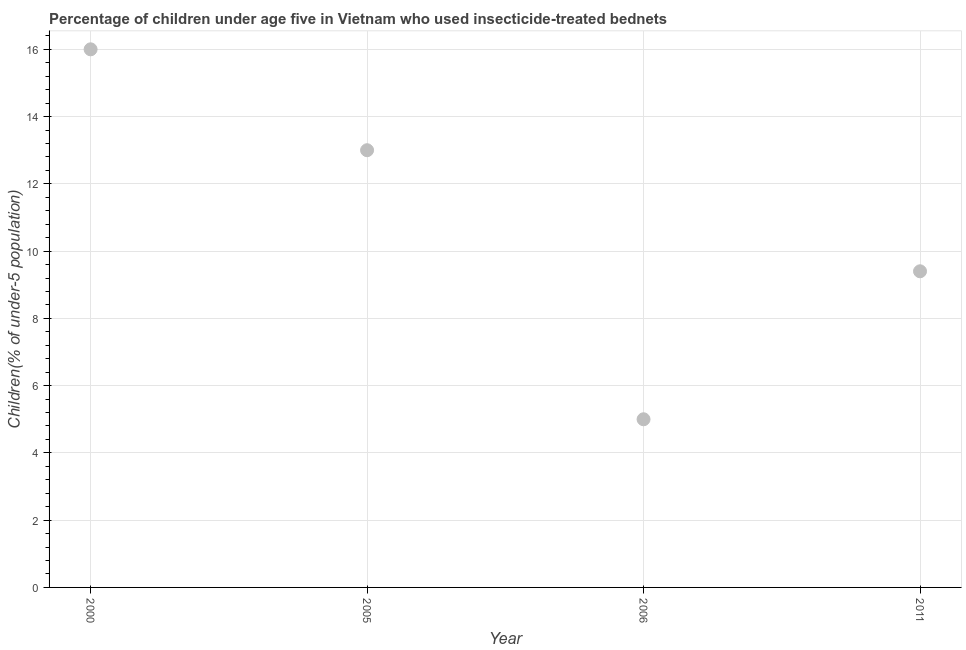What is the percentage of children who use of insecticide-treated bed nets in 2005?
Your answer should be compact. 13. Across all years, what is the maximum percentage of children who use of insecticide-treated bed nets?
Provide a short and direct response. 16. Across all years, what is the minimum percentage of children who use of insecticide-treated bed nets?
Offer a terse response. 5. In which year was the percentage of children who use of insecticide-treated bed nets maximum?
Offer a very short reply. 2000. In which year was the percentage of children who use of insecticide-treated bed nets minimum?
Provide a short and direct response. 2006. What is the sum of the percentage of children who use of insecticide-treated bed nets?
Offer a very short reply. 43.4. What is the average percentage of children who use of insecticide-treated bed nets per year?
Offer a terse response. 10.85. Do a majority of the years between 2005 and 2000 (inclusive) have percentage of children who use of insecticide-treated bed nets greater than 12.8 %?
Give a very brief answer. No. What is the ratio of the percentage of children who use of insecticide-treated bed nets in 2000 to that in 2011?
Offer a very short reply. 1.7. Is the difference between the percentage of children who use of insecticide-treated bed nets in 2005 and 2006 greater than the difference between any two years?
Give a very brief answer. No. What is the difference between the highest and the second highest percentage of children who use of insecticide-treated bed nets?
Give a very brief answer. 3. What is the difference between the highest and the lowest percentage of children who use of insecticide-treated bed nets?
Give a very brief answer. 11. Does the percentage of children who use of insecticide-treated bed nets monotonically increase over the years?
Provide a short and direct response. No. How many dotlines are there?
Your response must be concise. 1. How many years are there in the graph?
Provide a succinct answer. 4. What is the title of the graph?
Offer a terse response. Percentage of children under age five in Vietnam who used insecticide-treated bednets. What is the label or title of the X-axis?
Your answer should be very brief. Year. What is the label or title of the Y-axis?
Offer a very short reply. Children(% of under-5 population). What is the Children(% of under-5 population) in 2000?
Offer a very short reply. 16. What is the Children(% of under-5 population) in 2011?
Give a very brief answer. 9.4. What is the difference between the Children(% of under-5 population) in 2000 and 2006?
Give a very brief answer. 11. What is the ratio of the Children(% of under-5 population) in 2000 to that in 2005?
Provide a succinct answer. 1.23. What is the ratio of the Children(% of under-5 population) in 2000 to that in 2011?
Keep it short and to the point. 1.7. What is the ratio of the Children(% of under-5 population) in 2005 to that in 2011?
Make the answer very short. 1.38. What is the ratio of the Children(% of under-5 population) in 2006 to that in 2011?
Your answer should be compact. 0.53. 